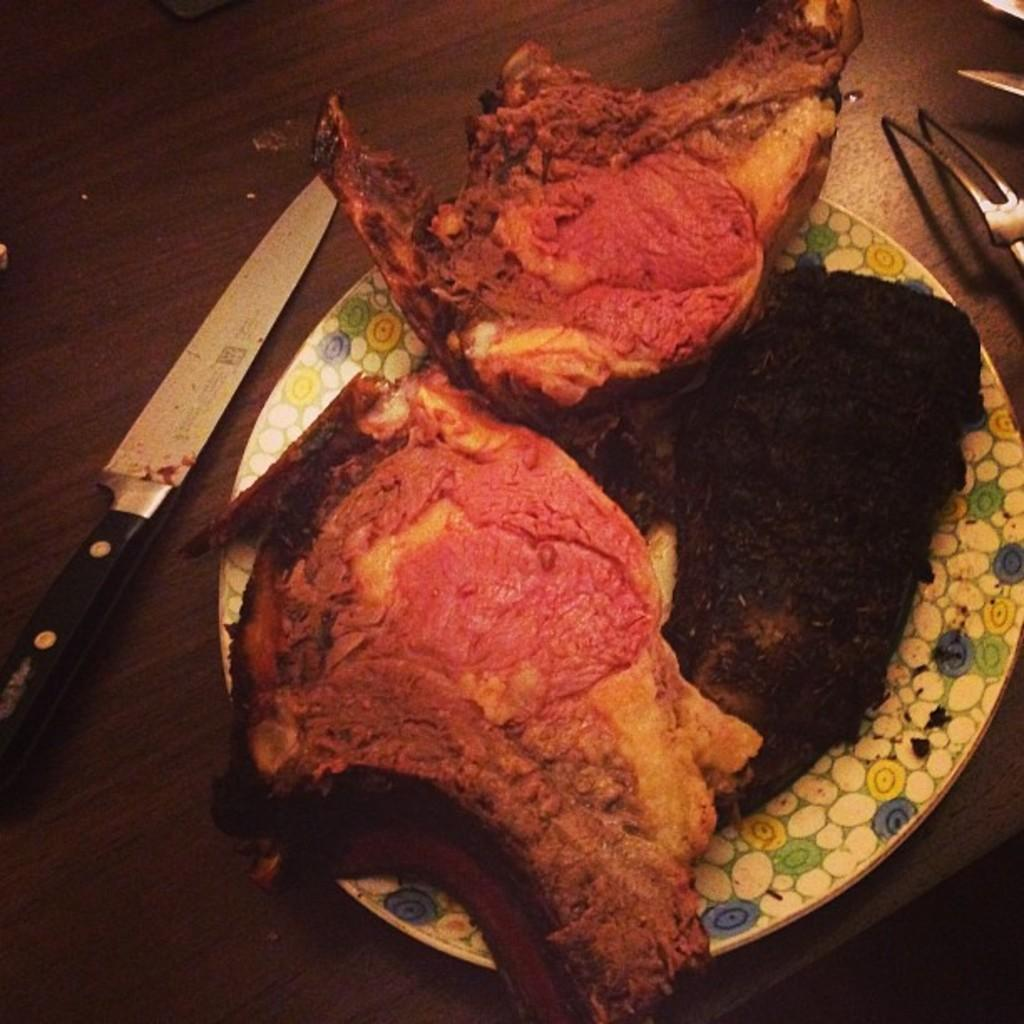What is on the plate in the image? There is food in the plate in the image. Can you describe any utensils visible in the image? Yes, there is a knife on the left side of the image. What type of light fixture is hanging above the food in the image? There is no light fixture visible in the image; it only shows a plate of food and a knife. 